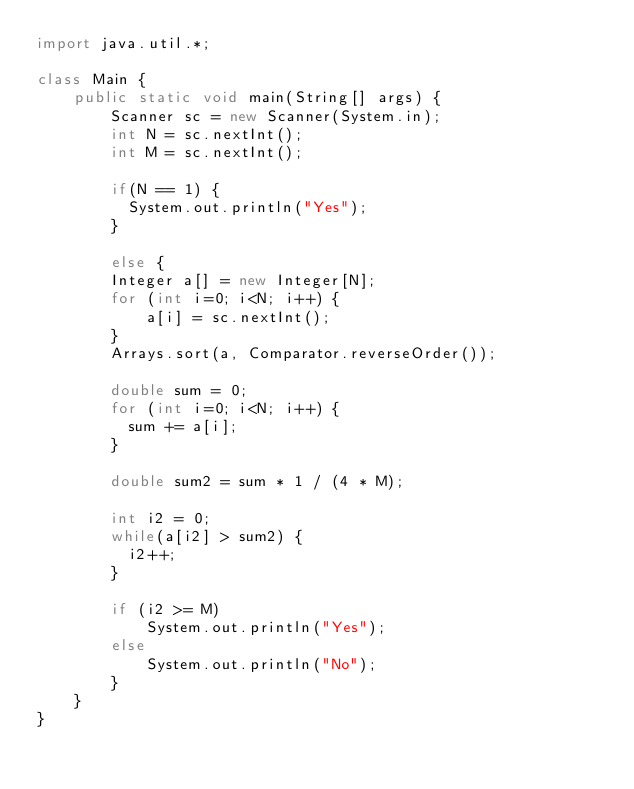Convert code to text. <code><loc_0><loc_0><loc_500><loc_500><_Java_>import java.util.*;

class Main {
    public static void main(String[] args) {
        Scanner sc = new Scanner(System.in);
        int N = sc.nextInt();
        int M = sc.nextInt();
      
      	if(N == 1) {
          System.out.println("Yes");
        }
        
        else {
      	Integer a[] = new Integer[N];
      	for (int i=0; i<N; i++) {
            a[i] = sc.nextInt();
        }
        Arrays.sort(a, Comparator.reverseOrder());
      
      	double sum = 0;
        for (int i=0; i<N; i++) {
          sum += a[i];
        }
      
      	double sum2 = sum * 1 / (4 * M);
          
        int i2 = 0;
      	while(a[i2] > sum2) {
          i2++;
        }
      	
      	if (i2 >= M)
            System.out.println("Yes");
        else
            System.out.println("No");
        }
    }
}</code> 